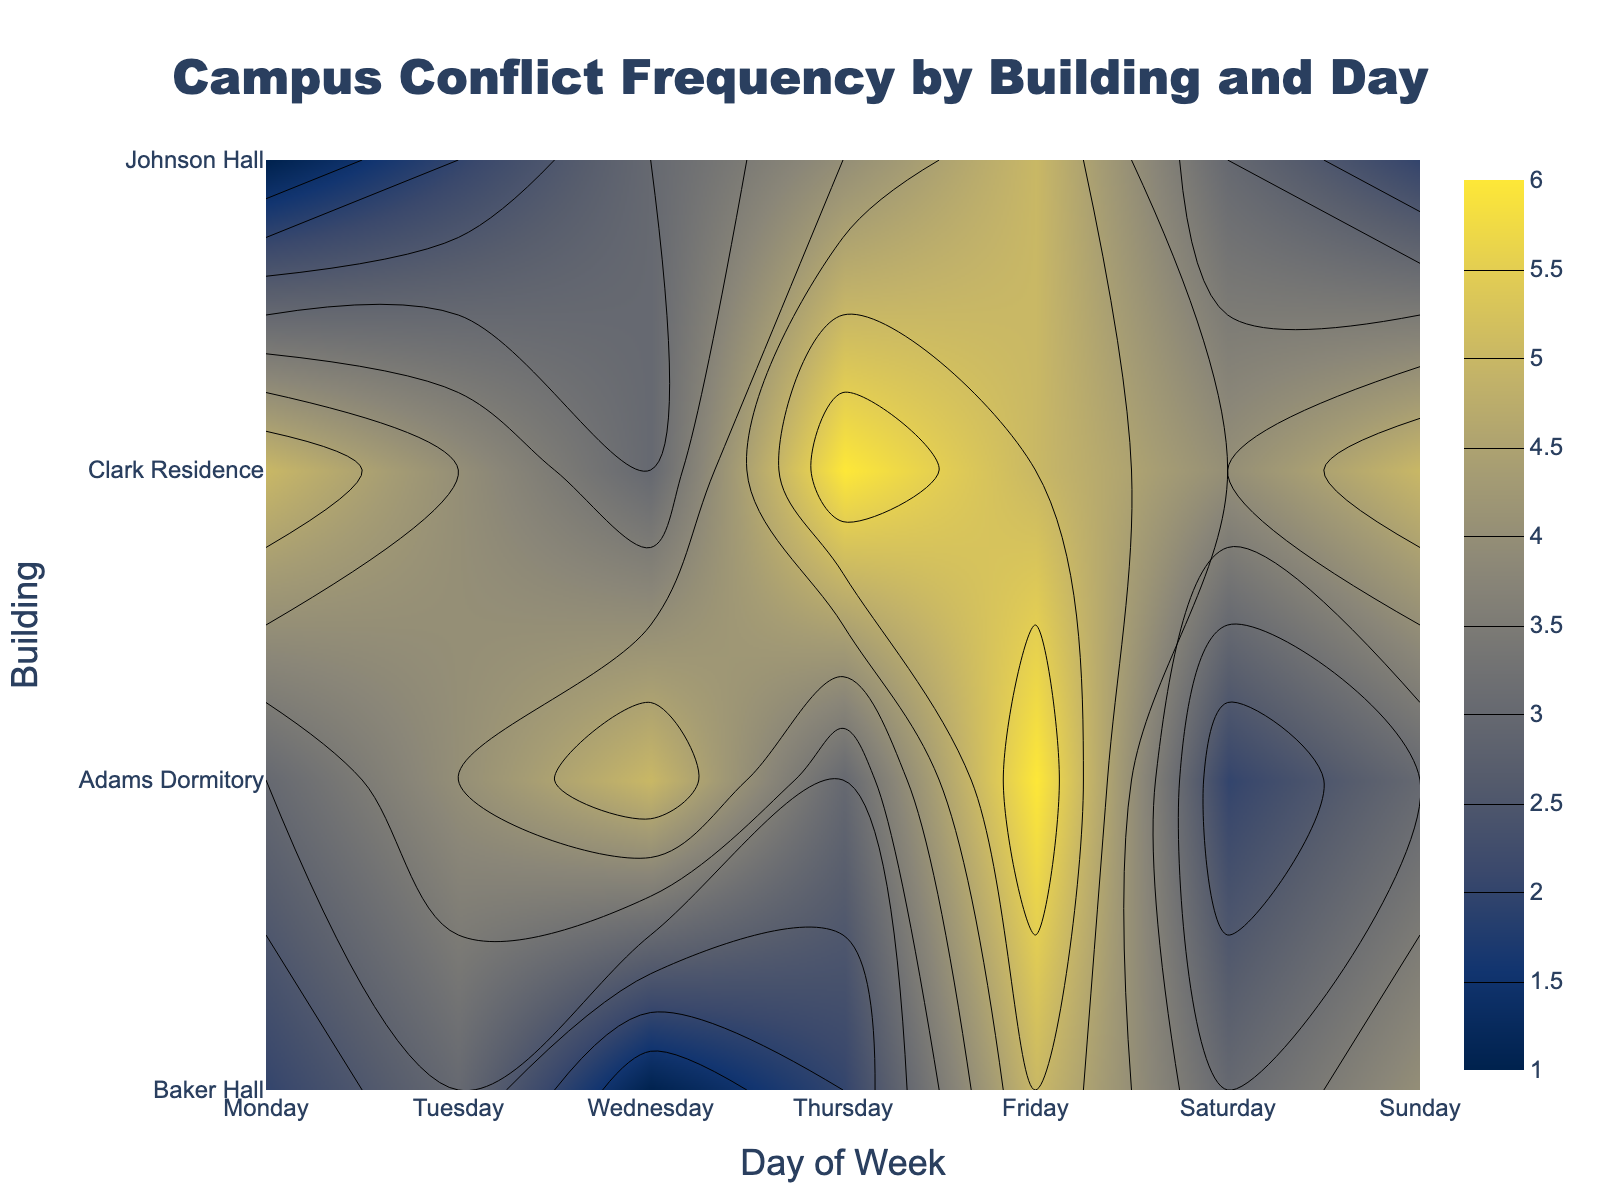What is the title of the figure? The title is located at the top center of the figure, and it is clearly written to indicate the content of the plot.
Answer: Campus Conflict Frequency by Building and Day Which building shows the highest frequency of verbal conflicts on Thursday? Look at the contour plot for verbal conflicts and find the value associated with Thursday on the y-axis for each building. The highest value corresponds to the building we are seeking.
Answer: Baker Hall On which day does Johnson Hall experience the highest frequency of physical conflicts? Examine the contour plot for physical conflicts and trace Johnson Hall on the y-axis. Identify the day on the x-axis where the color intensity is the greatest for this building.
Answer: Tuesday Comparing cyber conflict frequencies, which building has more conflicts on Friday, Baker Hall or Adams Dormitory? Look at the contour plot for cyber conflicts and compare the color intensity for Baker Hall and Adams Dormitory on Friday. Identify which building has a higher value.
Answer: Baker Hall What is the average frequency of verbal conflicts in Adams Dormitory over the week? Locate the contour plot for verbal conflicts and find the values for each day in Adams Dormitory. Add the values and divide by the number of days (7) to get the average. (6 + 5 + 7 + 4 + 6 + 5 + 3) / 7 = 5.14
Answer: 5.14 Are there any buildings that experience more cyber conflicts on weekends (Saturday and Sunday) than weekdays (Monday to Friday)? Check the contour plot for cyber conflicts for each building. Sum the values for weekends and compare with the sum of weekdays for each building to find the answer. Clarke Residence: (4+5) > (5+4+4+6+5) = 9 > 24 Adams Dormitory: (3+4) > (2+3+1+2+5) = 7 > 13
Answer: No Which day has the most consistent frequency of cyber conflicts across all dormitories? For each day, observe the cyber conflict contour plot and check the values for all buildings. The day with the least variation in color intensity across buildings reflects consistency.
Answer: Tuesday What type of conflict does Baker Hall experience most frequently throughout the week? Compare the contour plots for verbal, physical, and cyber conflicts horizontally across the entire week for Baker Hall. The plot with the highest average value indicates the most frequent conflict type.
Answer: Cyber Does Clark Residence have any days with a frequency of zero for physical conflicts? Examine the contour plot for physical conflicts and locate Clark Residence on the y-axis. Look for any days where the color indicates a value of zero.
Answer: Tuesday, Saturday 